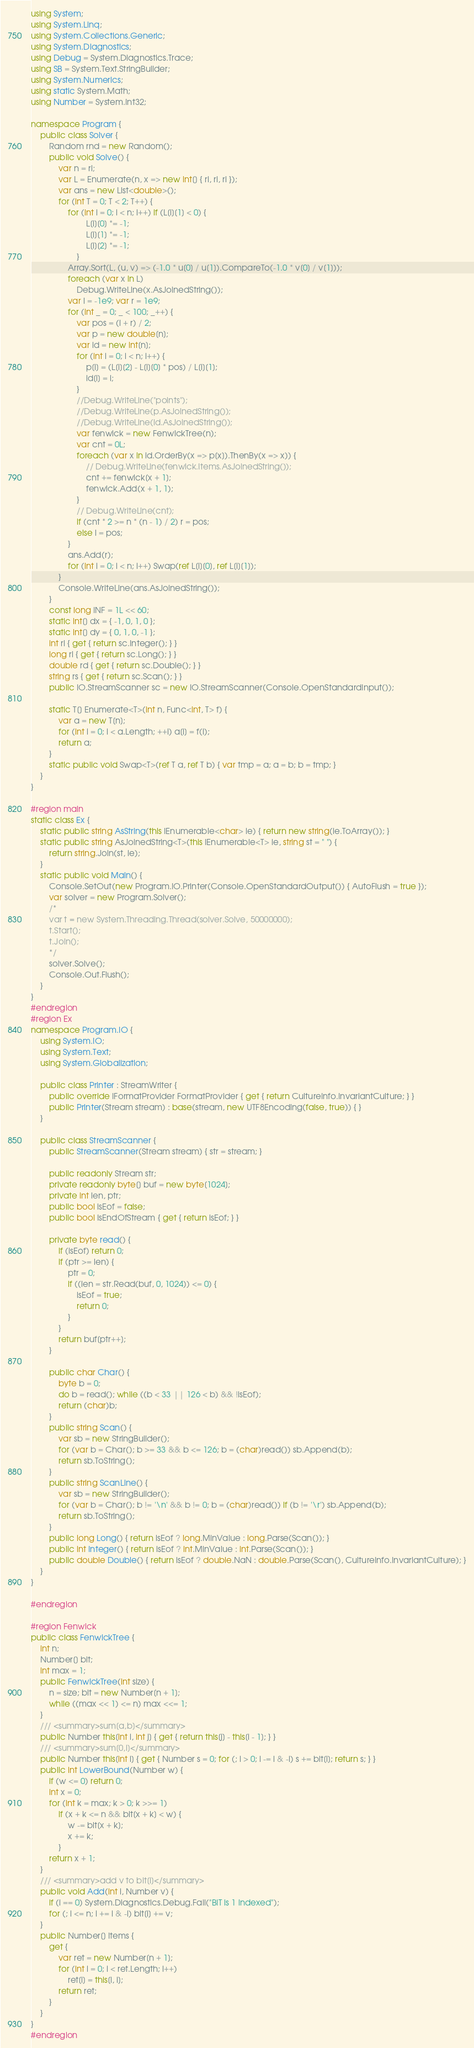<code> <loc_0><loc_0><loc_500><loc_500><_C#_>using System;
using System.Linq;
using System.Collections.Generic;
using System.Diagnostics;
using Debug = System.Diagnostics.Trace;
using SB = System.Text.StringBuilder;
using System.Numerics;
using static System.Math;
using Number = System.Int32;

namespace Program {
	public class Solver {
		Random rnd = new Random();
		public void Solve() {
			var n = ri;
			var L = Enumerate(n, x => new int[] { ri, ri, ri });
			var ans = new List<double>();
			for (int T = 0; T < 2; T++) {
				for (int i = 0; i < n; i++) if (L[i][1] < 0) {
						L[i][0] *= -1;
						L[i][1] *= -1;
						L[i][2] *= -1;
					}
				Array.Sort(L, (u, v) => (-1.0 * u[0] / u[1]).CompareTo(-1.0 * v[0] / v[1]));
				foreach (var x in L)
					Debug.WriteLine(x.AsJoinedString());
				var l = -1e9; var r = 1e9;
				for (int _ = 0; _ < 100; _++) {
					var pos = (l + r) / 2;
					var p = new double[n];
					var id = new int[n];
					for (int i = 0; i < n; i++) {
						p[i] = (L[i][2] - L[i][0] * pos) / L[i][1];
						id[i] = i;
					}
					//Debug.WriteLine("points");
					//Debug.WriteLine(p.AsJoinedString());
					//Debug.WriteLine(id.AsJoinedString());
					var fenwick = new FenwickTree(n);
					var cnt = 0L;
					foreach (var x in id.OrderBy(x => p[x]).ThenBy(x => x)) {
						// Debug.WriteLine(fenwick.Items.AsJoinedString());
						cnt += fenwick[x + 1];
						fenwick.Add(x + 1, 1);
					}
					// Debug.WriteLine(cnt);
					if (cnt * 2 >= n * (n - 1) / 2) r = pos;
					else l = pos;
				}
				ans.Add(r);
				for (int i = 0; i < n; i++) Swap(ref L[i][0], ref L[i][1]);
			}
			Console.WriteLine(ans.AsJoinedString());
		}
		const long INF = 1L << 60;
		static int[] dx = { -1, 0, 1, 0 };
		static int[] dy = { 0, 1, 0, -1 };
		int ri { get { return sc.Integer(); } }
		long rl { get { return sc.Long(); } }
		double rd { get { return sc.Double(); } }
		string rs { get { return sc.Scan(); } }
		public IO.StreamScanner sc = new IO.StreamScanner(Console.OpenStandardInput());

		static T[] Enumerate<T>(int n, Func<int, T> f) {
			var a = new T[n];
			for (int i = 0; i < a.Length; ++i) a[i] = f(i);
			return a;
		}
		static public void Swap<T>(ref T a, ref T b) { var tmp = a; a = b; b = tmp; }
	}
}

#region main
static class Ex {
	static public string AsString(this IEnumerable<char> ie) { return new string(ie.ToArray()); }
	static public string AsJoinedString<T>(this IEnumerable<T> ie, string st = " ") {
		return string.Join(st, ie);
	}
	static public void Main() {
		Console.SetOut(new Program.IO.Printer(Console.OpenStandardOutput()) { AutoFlush = true });
		var solver = new Program.Solver();
		/* 
		var t = new System.Threading.Thread(solver.Solve, 50000000);
		t.Start();
		t.Join();
		*/
		solver.Solve();
		Console.Out.Flush();
	}
}
#endregion
#region Ex
namespace Program.IO {
	using System.IO;
	using System.Text;
	using System.Globalization;

	public class Printer : StreamWriter {
		public override IFormatProvider FormatProvider { get { return CultureInfo.InvariantCulture; } }
		public Printer(Stream stream) : base(stream, new UTF8Encoding(false, true)) { }
	}

	public class StreamScanner {
		public StreamScanner(Stream stream) { str = stream; }

		public readonly Stream str;
		private readonly byte[] buf = new byte[1024];
		private int len, ptr;
		public bool isEof = false;
		public bool IsEndOfStream { get { return isEof; } }

		private byte read() {
			if (isEof) return 0;
			if (ptr >= len) {
				ptr = 0;
				if ((len = str.Read(buf, 0, 1024)) <= 0) {
					isEof = true;
					return 0;
				}
			}
			return buf[ptr++];
		}

		public char Char() {
			byte b = 0;
			do b = read(); while ((b < 33 || 126 < b) && !isEof);
			return (char)b;
		}
		public string Scan() {
			var sb = new StringBuilder();
			for (var b = Char(); b >= 33 && b <= 126; b = (char)read()) sb.Append(b);
			return sb.ToString();
		}
		public string ScanLine() {
			var sb = new StringBuilder();
			for (var b = Char(); b != '\n' && b != 0; b = (char)read()) if (b != '\r') sb.Append(b);
			return sb.ToString();
		}
		public long Long() { return isEof ? long.MinValue : long.Parse(Scan()); }
		public int Integer() { return isEof ? int.MinValue : int.Parse(Scan()); }
		public double Double() { return isEof ? double.NaN : double.Parse(Scan(), CultureInfo.InvariantCulture); }
	}
}

#endregion

#region Fenwick
public class FenwickTree {
	int n;
	Number[] bit;
	int max = 1;
	public FenwickTree(int size) {
		n = size; bit = new Number[n + 1];
		while ((max << 1) <= n) max <<= 1;
	}
	/// <summary>sum[a,b]</summary>
	public Number this[int i, int j] { get { return this[j] - this[i - 1]; } }
	/// <summary>sum[0,i]</summary>
	public Number this[int i] { get { Number s = 0; for (; i > 0; i -= i & -i) s += bit[i]; return s; } }
	public int LowerBound(Number w) {
		if (w <= 0) return 0;
		int x = 0;
		for (int k = max; k > 0; k >>= 1)
			if (x + k <= n && bit[x + k] < w) {
				w -= bit[x + k];
				x += k;
			}
		return x + 1;
	}
	/// <summary>add v to bit[i]</summary>
	public void Add(int i, Number v) {
		if (i == 0) System.Diagnostics.Debug.Fail("BIT is 1 indexed");
		for (; i <= n; i += i & -i) bit[i] += v;
	}
	public Number[] Items {
		get {
			var ret = new Number[n + 1];
			for (int i = 0; i < ret.Length; i++)
				ret[i] = this[i, i];
			return ret;
		}
	}
}
#endregion
</code> 